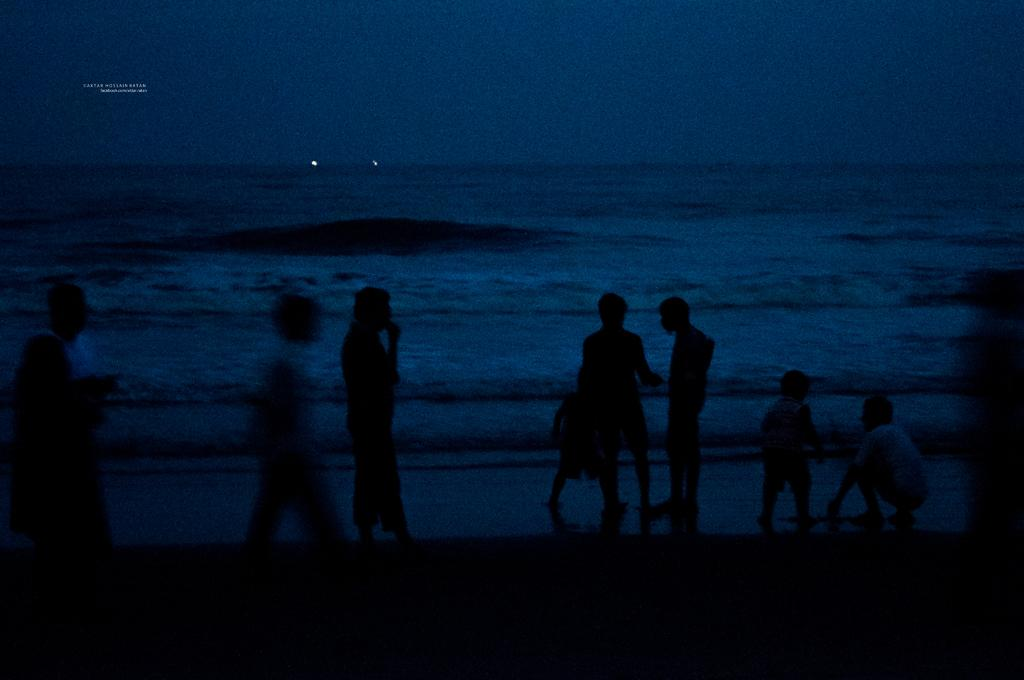Who or what can be seen in the image? There are people in the image. Where are the people located? The people are on the beach. What can be seen in the background of the image? There is water visible in the background of the image. What type of flooring can be seen on the beach in the image? There is no flooring visible on the beach in the image, as it is a natural environment with sand and water. 